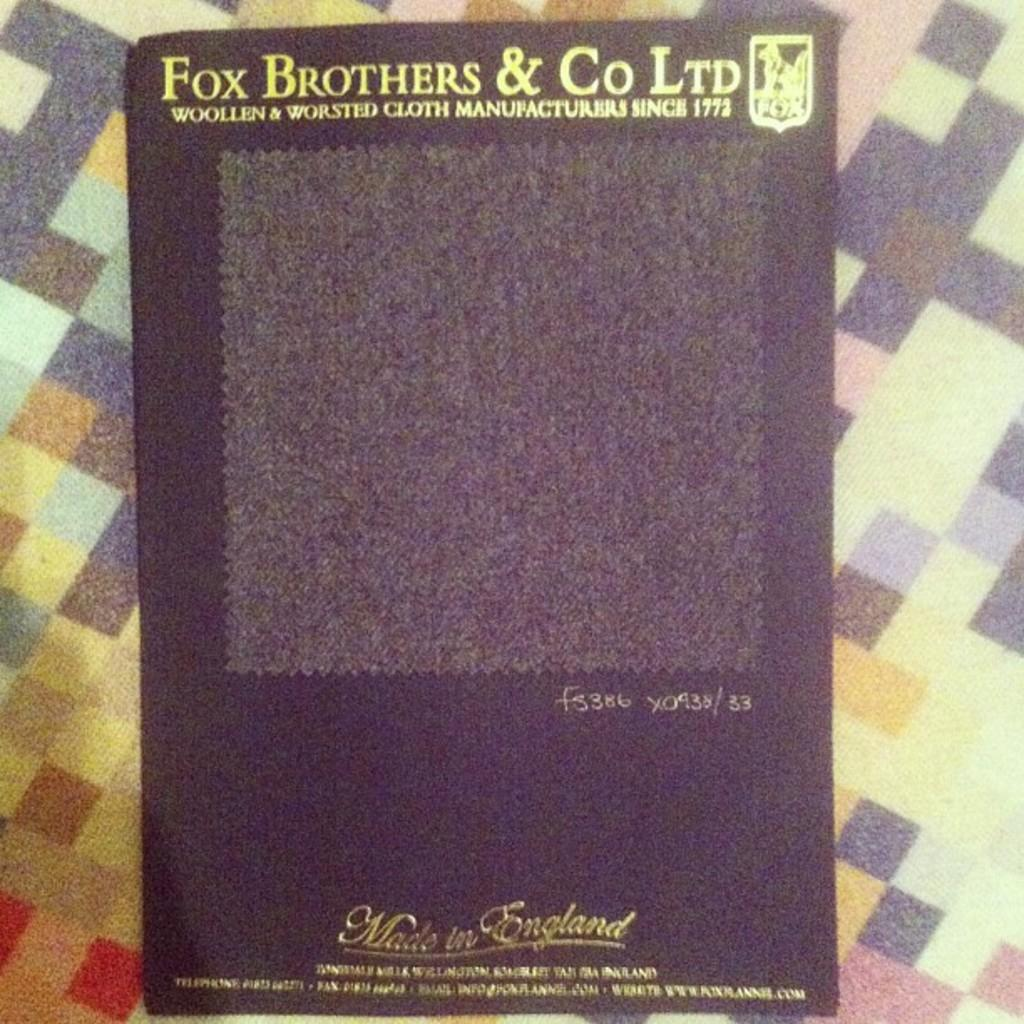<image>
Give a short and clear explanation of the subsequent image. A package of English made cloth is sold by Fox Brothers and Company. 